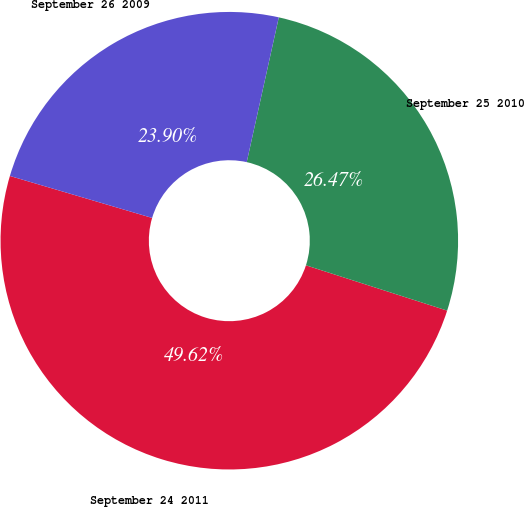Convert chart. <chart><loc_0><loc_0><loc_500><loc_500><pie_chart><fcel>September 24 2011<fcel>September 25 2010<fcel>September 26 2009<nl><fcel>49.62%<fcel>26.47%<fcel>23.9%<nl></chart> 